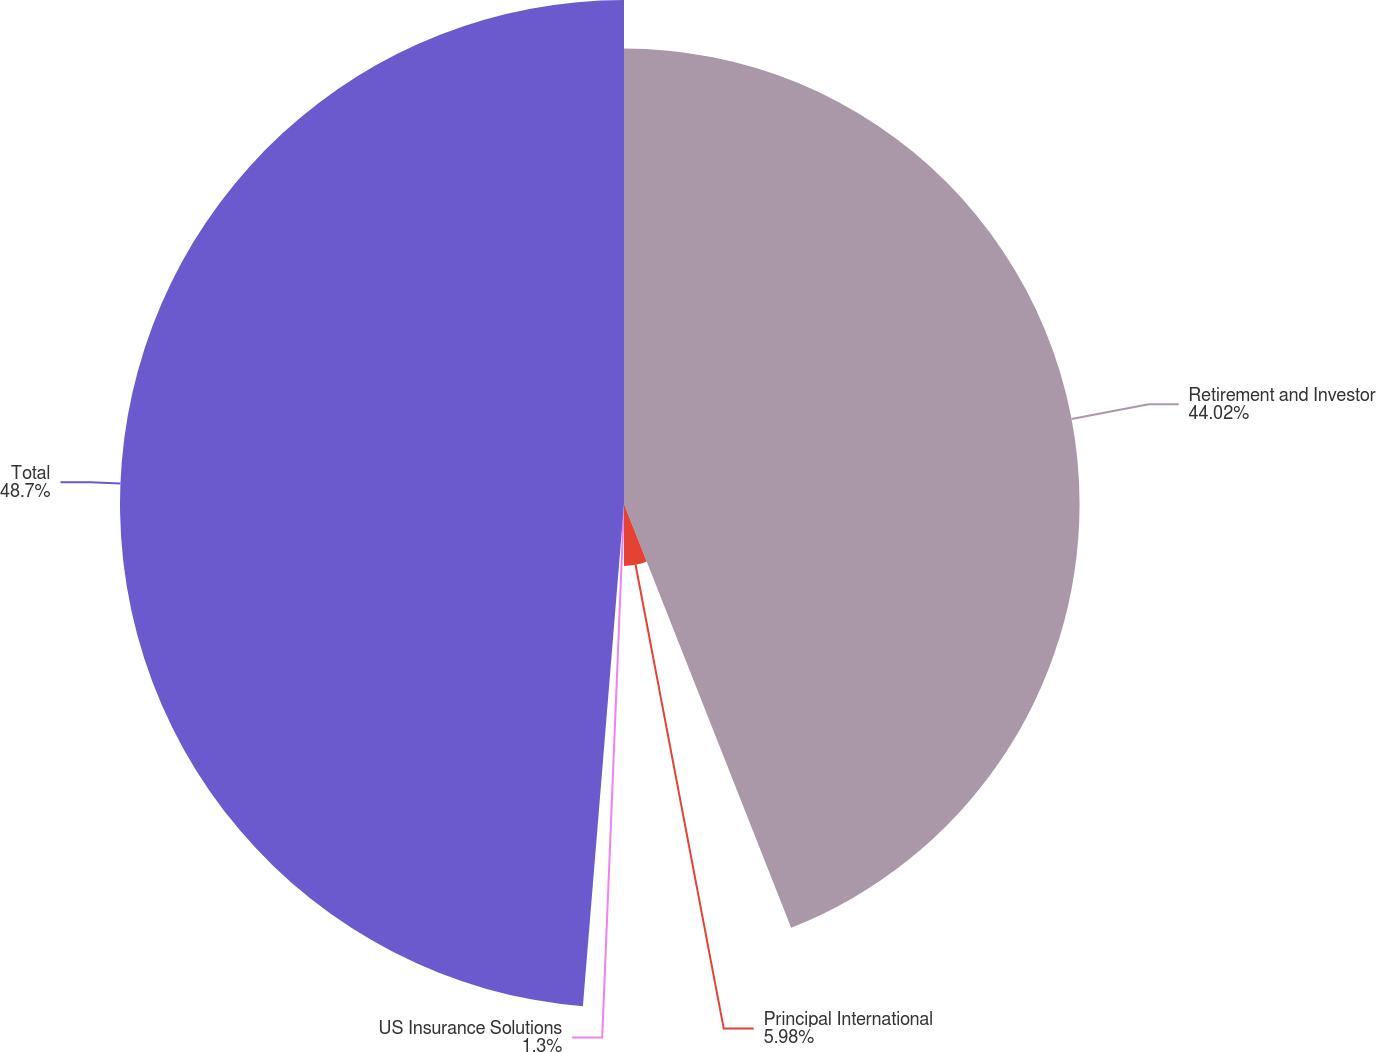Convert chart to OTSL. <chart><loc_0><loc_0><loc_500><loc_500><pie_chart><fcel>Retirement and Investor<fcel>Principal International<fcel>US Insurance Solutions<fcel>Total<nl><fcel>44.02%<fcel>5.98%<fcel>1.3%<fcel>48.7%<nl></chart> 